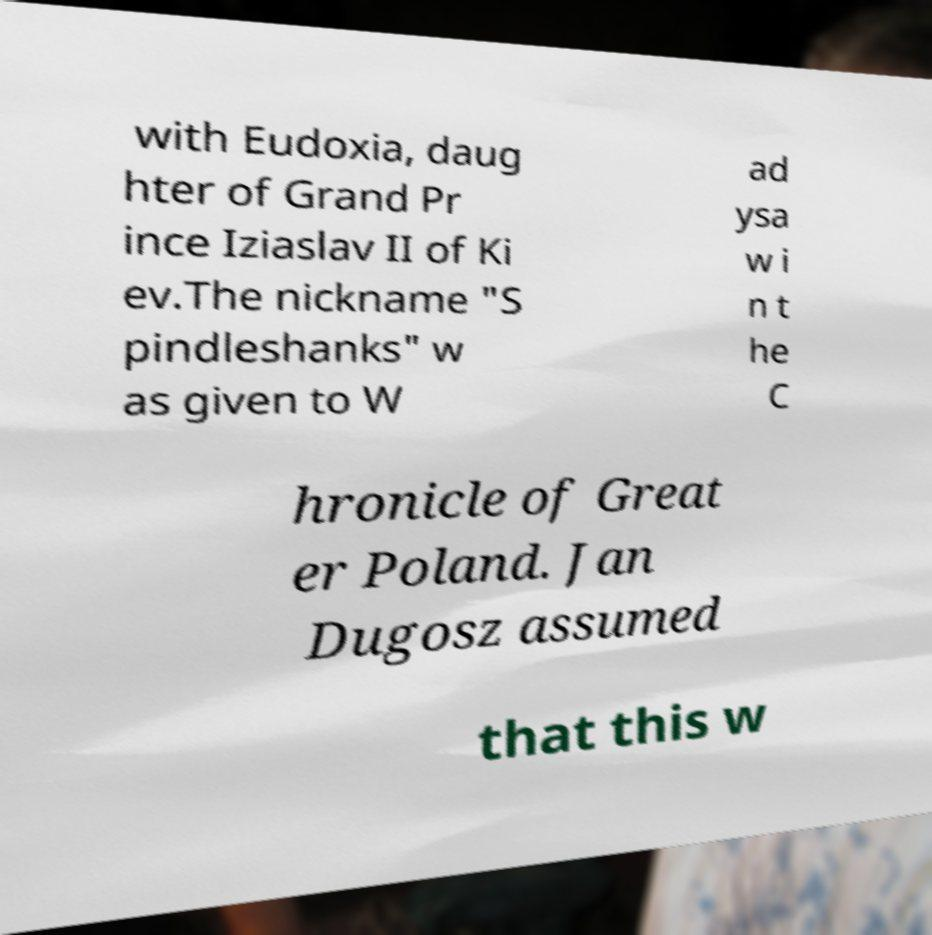Please identify and transcribe the text found in this image. with Eudoxia, daug hter of Grand Pr ince Iziaslav II of Ki ev.The nickname "S pindleshanks" w as given to W ad ysa w i n t he C hronicle of Great er Poland. Jan Dugosz assumed that this w 